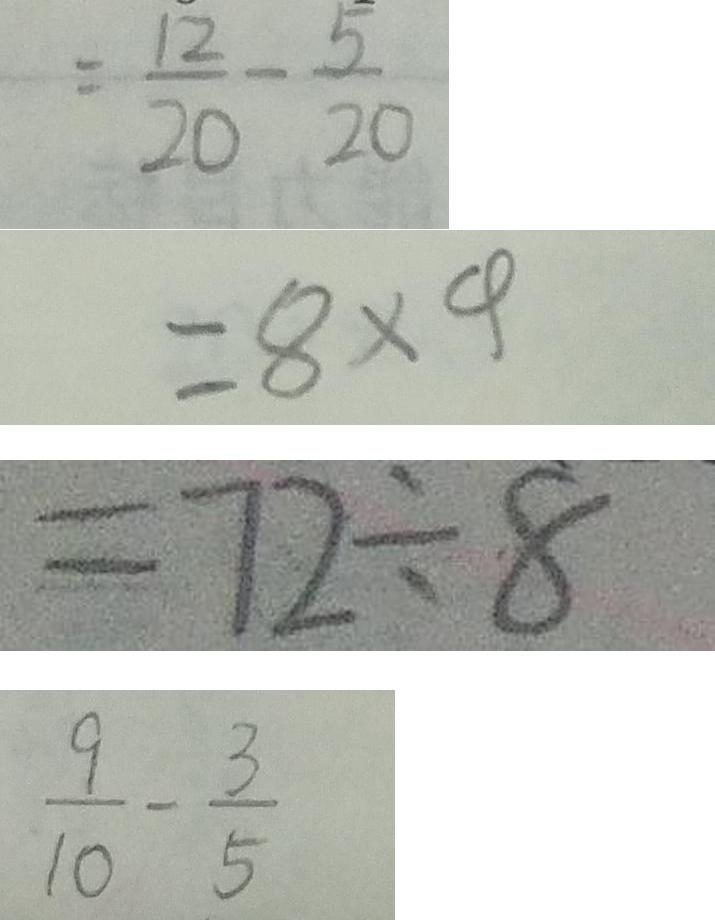<formula> <loc_0><loc_0><loc_500><loc_500>= \frac { 1 2 } { 2 0 } - \frac { 5 } { 2 0 } 
 = 8 \times 4 
 = 7 2 \div 8 
 \frac { 9 } { 1 0 } - \frac { 3 } { 5 }</formula> 